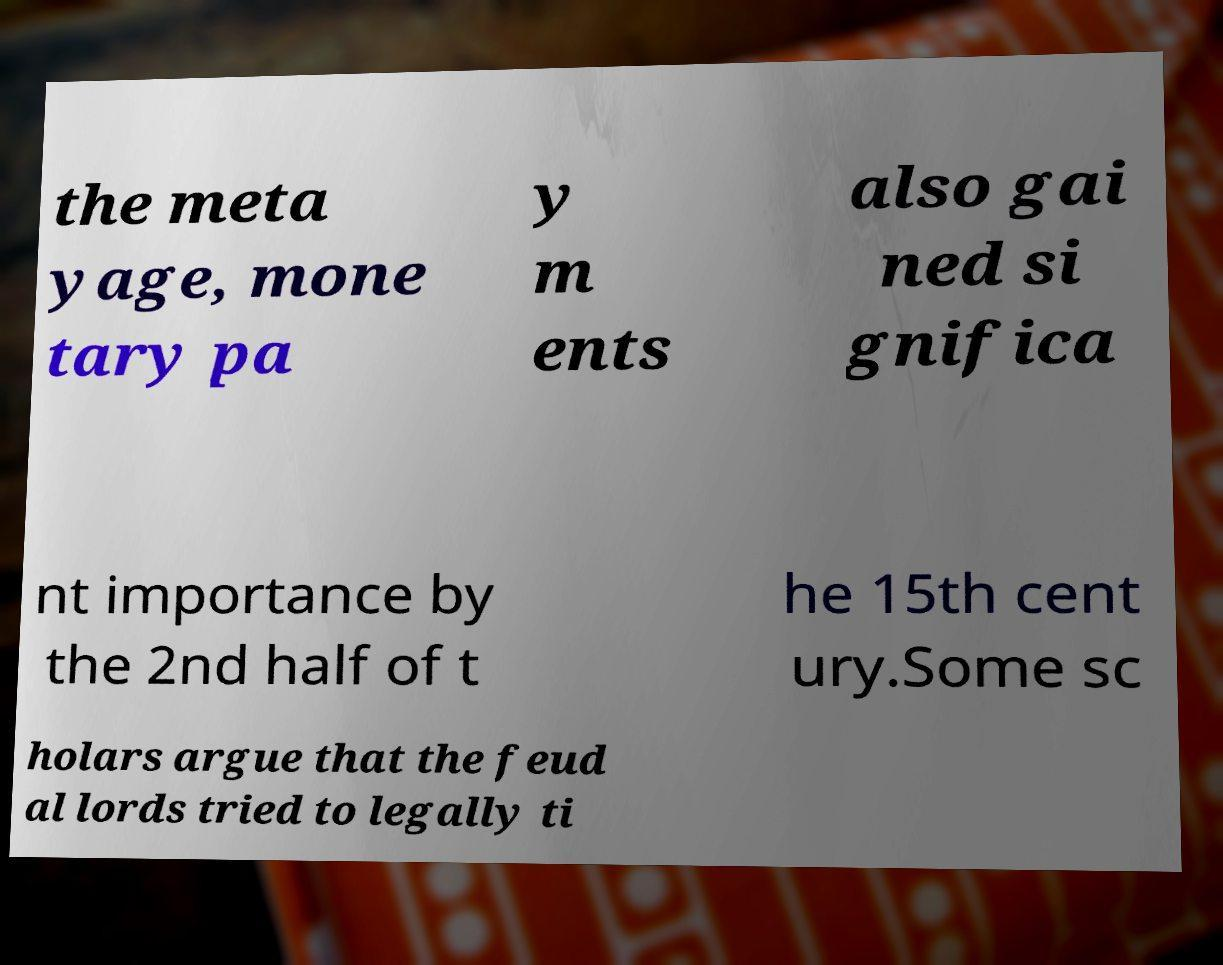Could you assist in decoding the text presented in this image and type it out clearly? the meta yage, mone tary pa y m ents also gai ned si gnifica nt importance by the 2nd half of t he 15th cent ury.Some sc holars argue that the feud al lords tried to legally ti 